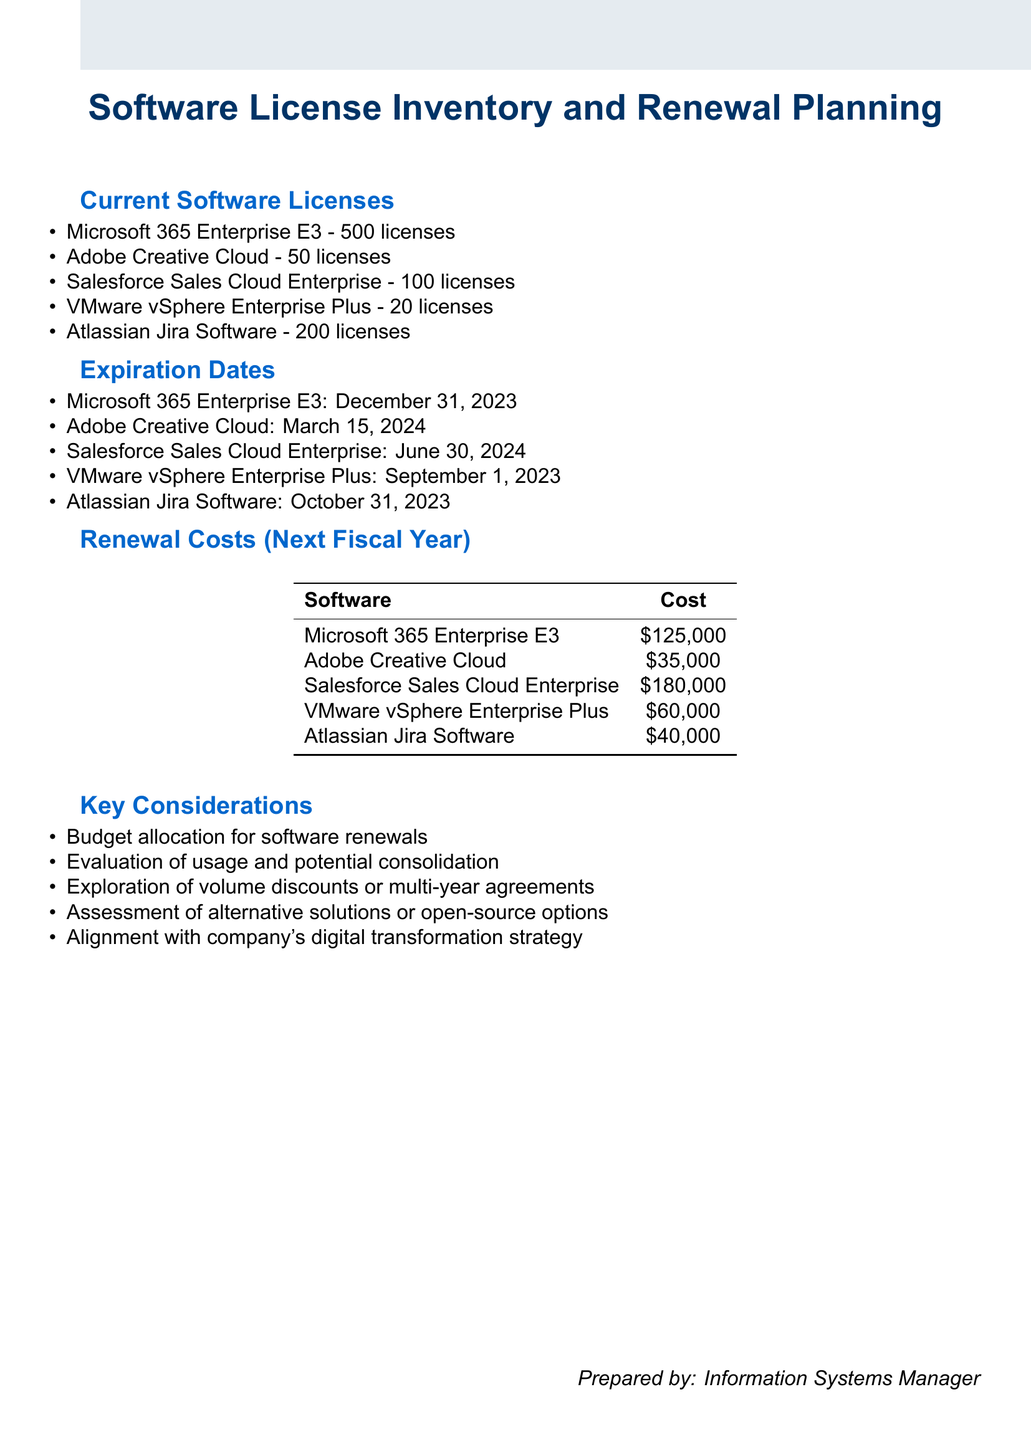What is the total number of licenses for Microsoft 365 Enterprise E3? The document states there are 500 licenses for Microsoft 365 Enterprise E3.
Answer: 500 licenses When does the Adobe Creative Cloud license expire? The expiration date for Adobe Creative Cloud is mentioned in the document as March 15, 2024.
Answer: March 15, 2024 What is the renewal cost for Salesforce Sales Cloud Enterprise? The document specifies that the renewal cost for Salesforce Sales Cloud Enterprise is $180,000.
Answer: $180,000 Which software license expires last? By evaluating the expiration dates provided, Salesforce Sales Cloud Enterprise has the latest expiration date of June 30, 2024.
Answer: June 30, 2024 What is a key consideration mentioned in the document regarding software renewals? The document lists multiple key considerations, one being "Budget allocation for software renewals."
Answer: Budget allocation for software renewals How many licenses are allocated for Atlassian Jira Software? The document states there are 200 licenses allocated for Atlassian Jira Software.
Answer: 200 licenses What is the expiration date for VMware vSphere Enterprise Plus? According to the document, the expiration date for VMware vSphere Enterprise Plus is September 1, 2023.
Answer: September 1, 2023 What is the total renewal cost for all listed software licenses for the next fiscal year? The total renewal cost is calculated by adding all renewal costs: $125,000 + $35,000 + $180,000 + $60,000 + $40,000 = $440,000.
Answer: $440,000 